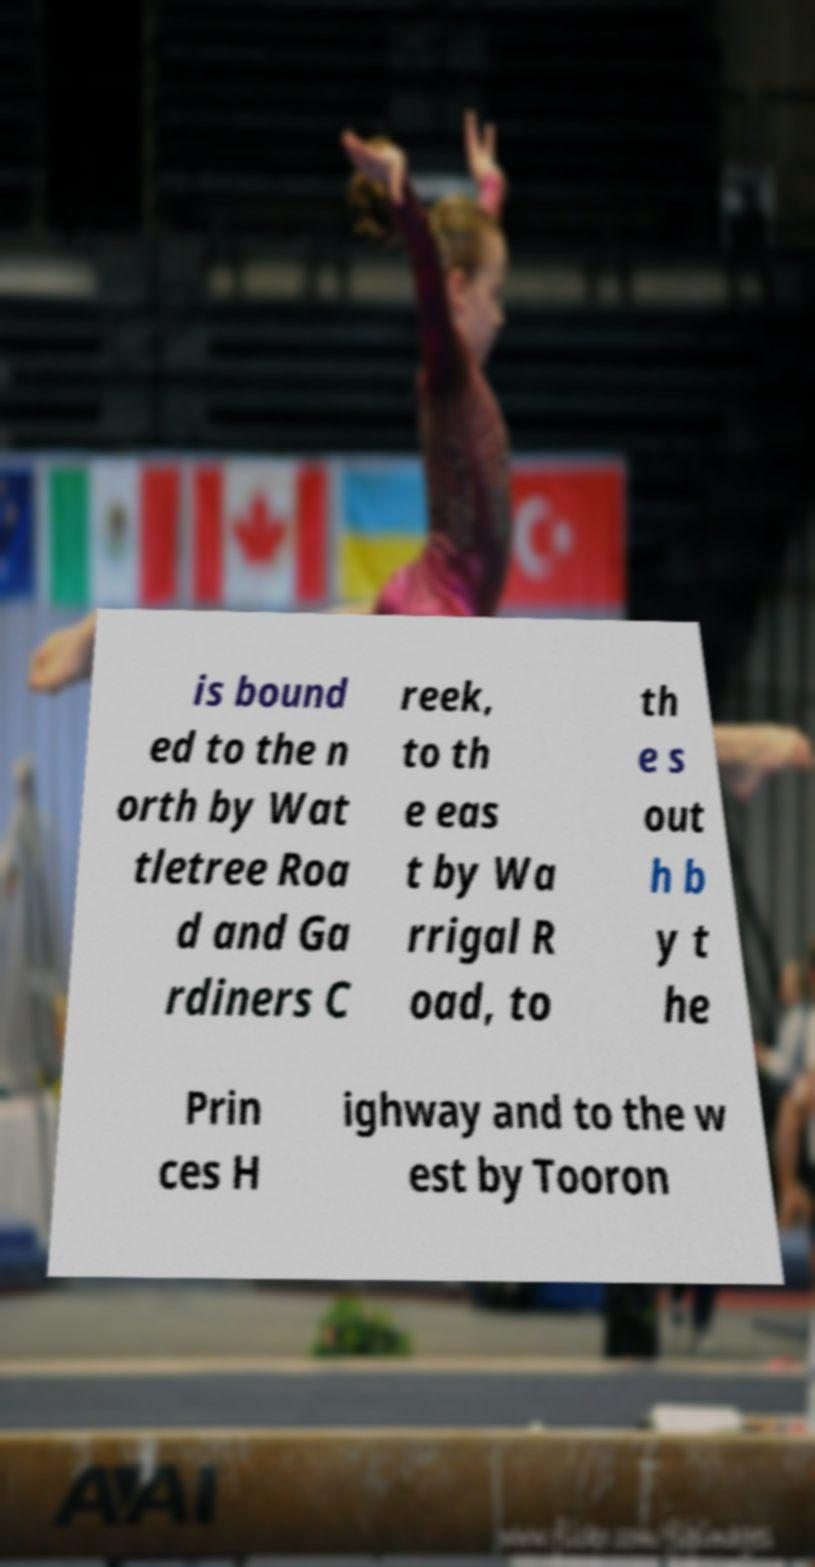Can you read and provide the text displayed in the image?This photo seems to have some interesting text. Can you extract and type it out for me? is bound ed to the n orth by Wat tletree Roa d and Ga rdiners C reek, to th e eas t by Wa rrigal R oad, to th e s out h b y t he Prin ces H ighway and to the w est by Tooron 